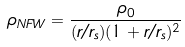Convert formula to latex. <formula><loc_0><loc_0><loc_500><loc_500>\rho _ { N F W } = \frac { \rho _ { 0 } } { ( r / r _ { s } ) ( 1 + r / r _ { s } ) ^ { 2 } }</formula> 